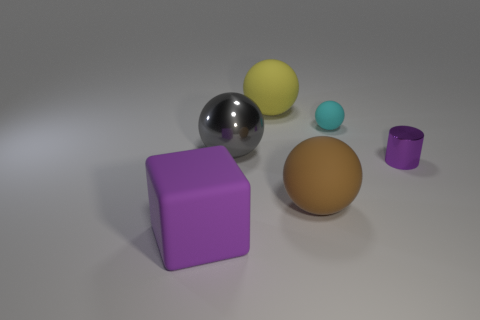Are there more tiny rubber balls than blue rubber cylinders?
Ensure brevity in your answer.  Yes. Are there any purple matte cylinders that have the same size as the purple cube?
Your response must be concise. No. How many objects are large objects that are in front of the cyan matte sphere or large rubber objects that are behind the metallic cylinder?
Your response must be concise. 4. What color is the sphere to the left of the large rubber sphere behind the gray shiny ball?
Give a very brief answer. Gray. What color is the other large sphere that is made of the same material as the big brown ball?
Your response must be concise. Yellow. What number of shiny cylinders have the same color as the big cube?
Provide a succinct answer. 1. What number of things are either big green spheres or spheres?
Offer a terse response. 4. What shape is the yellow thing that is the same size as the purple matte thing?
Keep it short and to the point. Sphere. What number of large rubber objects are both left of the big yellow object and right of the big yellow rubber thing?
Ensure brevity in your answer.  0. What is the material of the purple object that is to the left of the yellow rubber sphere?
Your answer should be compact. Rubber. 